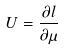<formula> <loc_0><loc_0><loc_500><loc_500>U = \frac { \partial l } { \partial \mu }</formula> 